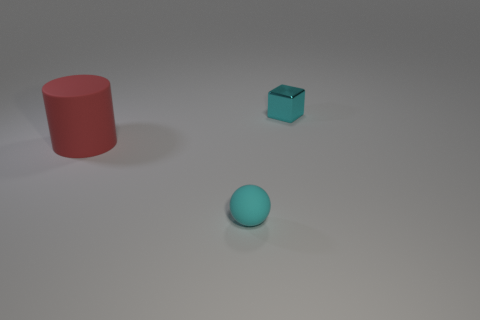Is there anything else that is the same shape as the tiny cyan metal object?
Make the answer very short. No. Is there a small shiny cube that is behind the tiny cyan object on the right side of the small sphere?
Provide a succinct answer. No. What is the material of the red cylinder?
Your answer should be very brief. Rubber. There is a cyan matte ball; are there any cyan objects behind it?
Offer a terse response. Yes. Are there the same number of big red matte objects left of the matte cylinder and cyan cubes that are behind the small sphere?
Give a very brief answer. No. How many cylinders are there?
Make the answer very short. 1. Is the number of small things in front of the large red matte object greater than the number of small blue spheres?
Your answer should be very brief. Yes. There is a cyan object behind the big object; what is it made of?
Your answer should be compact. Metal. How many matte spheres are the same color as the cube?
Ensure brevity in your answer.  1. There is a object that is left of the ball; does it have the same size as the cyan object in front of the red rubber cylinder?
Provide a succinct answer. No. 